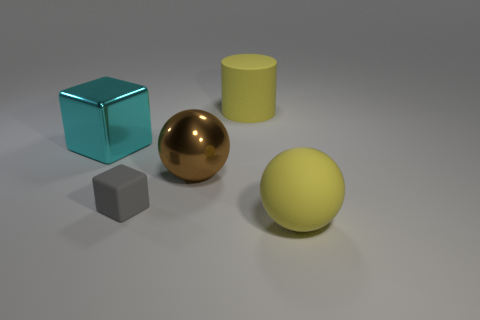What number of yellow rubber balls are the same size as the rubber block?
Offer a very short reply. 0. There is a object in front of the tiny gray thing; is there a yellow matte sphere in front of it?
Your response must be concise. No. How many things are either cylinders or big yellow matte balls?
Make the answer very short. 2. What is the color of the large ball that is right of the big brown thing that is on the right side of the shiny thing that is to the left of the small object?
Provide a short and direct response. Yellow. Is there anything else of the same color as the tiny block?
Keep it short and to the point. No. Do the gray rubber object and the cylinder have the same size?
Ensure brevity in your answer.  No. How many objects are cubes that are in front of the large cyan block or yellow matte objects that are behind the brown shiny ball?
Keep it short and to the point. 2. The sphere to the left of the ball on the right side of the brown metal thing is made of what material?
Your answer should be very brief. Metal. What number of other objects are there of the same material as the cyan thing?
Make the answer very short. 1. Is the shape of the small matte thing the same as the large brown object?
Keep it short and to the point. No. 